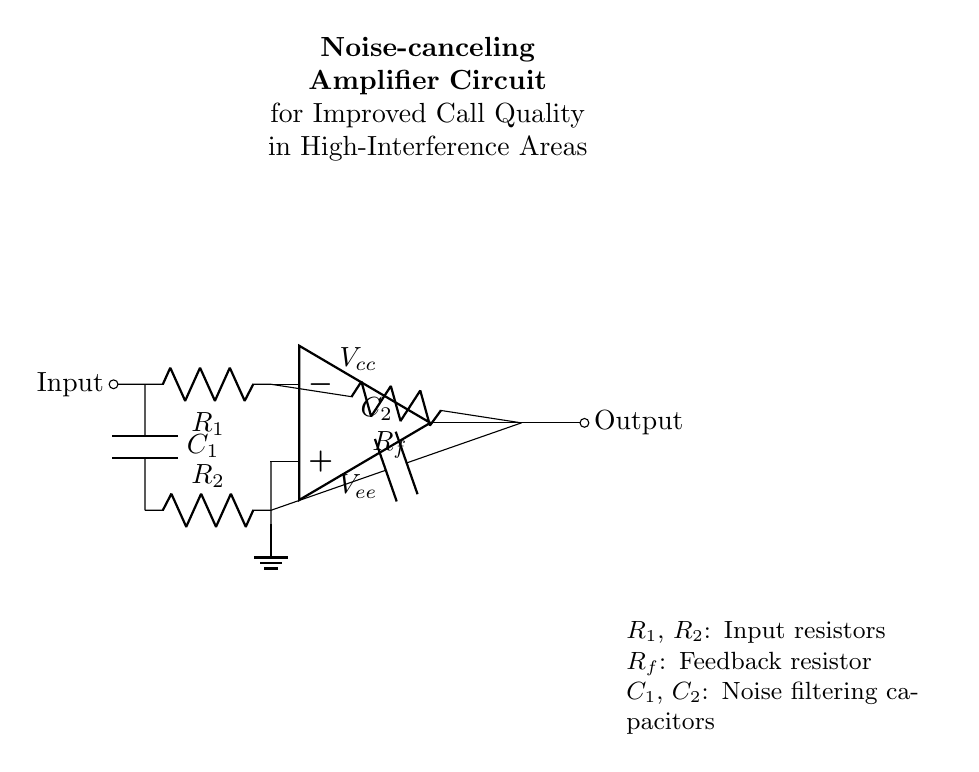What is the type of amplifier used in this circuit? The circuit diagram indicates that an operational amplifier is used, identifiable by the symbol labeled as 'op amp'.
Answer: operational amplifier What components are used for noise filtering? The circuit includes two capacitors labeled C1 and C2, which serve the purpose of filtering out noise.
Answer: C1, C2 What is the role of Rf in the circuit? Resistor Rf functions as a feedback resistor, connecting the output of the operational amplifier back to its inverting input.
Answer: feedback resistor What does R1 connect to in the circuit? R1 connects the input signal to the inverting input of the operational amplifier, allowing the circuit to process the incoming audio signal.
Answer: inverting input How many resistors are present in the circuit? There are three resistors in the circuit: R1, R2, and Rf.
Answer: three Which voltage sources are indicated in the circuit? The voltages labeled are Vcc (positive supply voltage) and Vee (negative supply voltage), both essential for the operational amplifier's function.
Answer: Vcc, Vee What is the expected effect of the circuit on call quality? This circuit aims to improve call quality by cancelling out noise, particularly in high-interference environments, enhancing clarity in communication.
Answer: improved call quality 